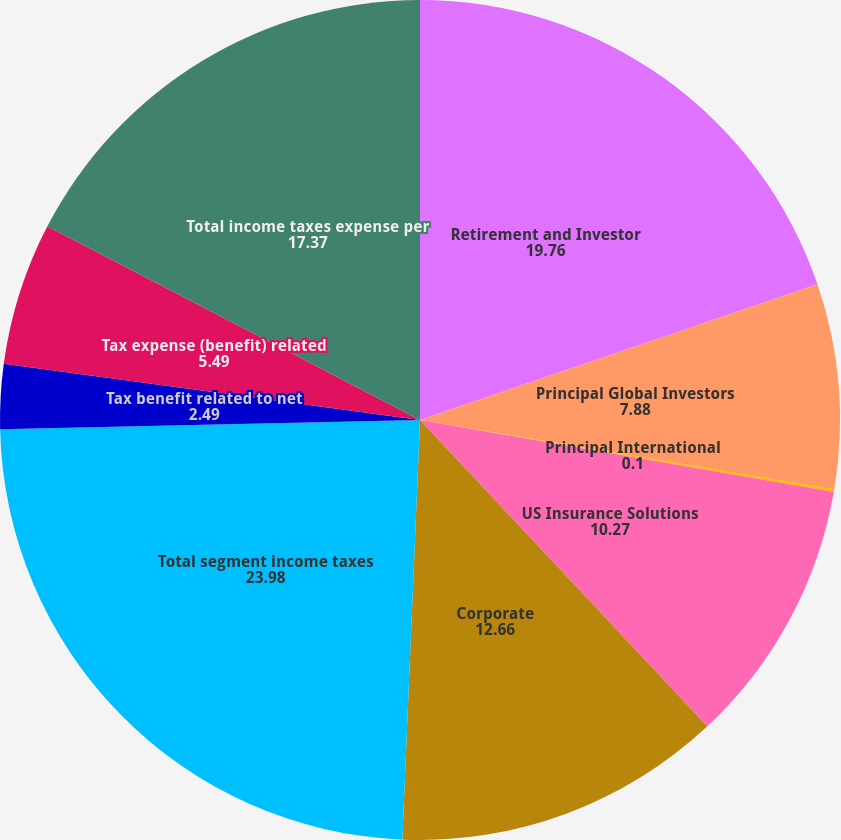Convert chart. <chart><loc_0><loc_0><loc_500><loc_500><pie_chart><fcel>Retirement and Investor<fcel>Principal Global Investors<fcel>Principal International<fcel>US Insurance Solutions<fcel>Corporate<fcel>Total segment income taxes<fcel>Tax benefit related to net<fcel>Tax expense (benefit) related<fcel>Total income taxes expense per<nl><fcel>19.76%<fcel>7.88%<fcel>0.1%<fcel>10.27%<fcel>12.66%<fcel>23.98%<fcel>2.49%<fcel>5.49%<fcel>17.37%<nl></chart> 